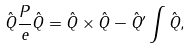Convert formula to latex. <formula><loc_0><loc_0><loc_500><loc_500>\hat { Q } \frac { P } { e } \hat { Q } = \hat { Q } \times \hat { Q } - \hat { Q } ^ { \prime } \int \hat { Q } ,</formula> 